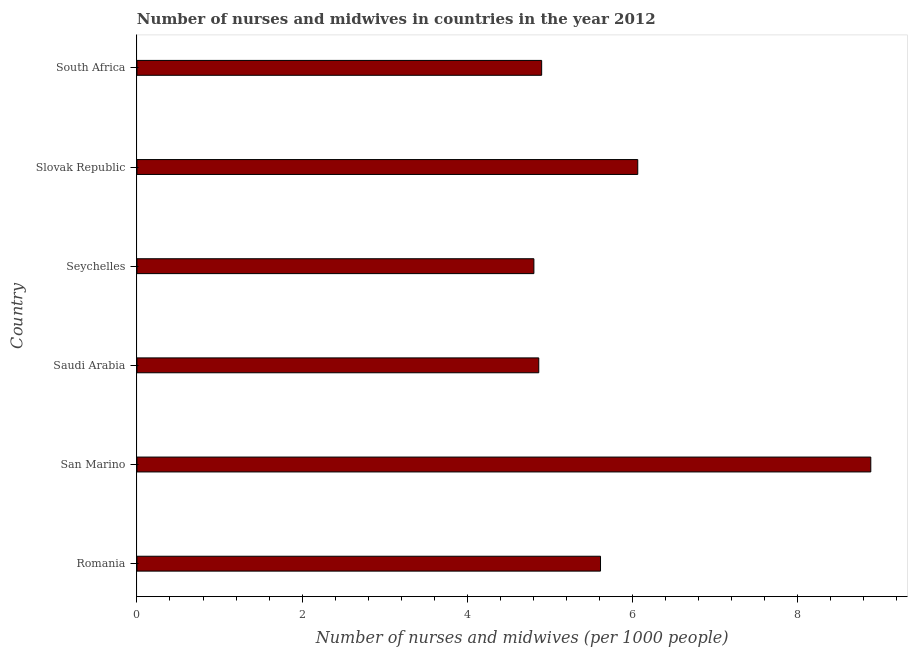Does the graph contain any zero values?
Provide a short and direct response. No. Does the graph contain grids?
Provide a succinct answer. No. What is the title of the graph?
Ensure brevity in your answer.  Number of nurses and midwives in countries in the year 2012. What is the label or title of the X-axis?
Your answer should be compact. Number of nurses and midwives (per 1000 people). What is the label or title of the Y-axis?
Make the answer very short. Country. What is the number of nurses and midwives in Romania?
Provide a short and direct response. 5.62. Across all countries, what is the maximum number of nurses and midwives?
Your answer should be very brief. 8.89. Across all countries, what is the minimum number of nurses and midwives?
Ensure brevity in your answer.  4.81. In which country was the number of nurses and midwives maximum?
Ensure brevity in your answer.  San Marino. In which country was the number of nurses and midwives minimum?
Offer a very short reply. Seychelles. What is the sum of the number of nurses and midwives?
Offer a very short reply. 35.15. What is the difference between the number of nurses and midwives in Romania and Seychelles?
Keep it short and to the point. 0.81. What is the average number of nurses and midwives per country?
Make the answer very short. 5.86. What is the median number of nurses and midwives?
Make the answer very short. 5.26. In how many countries, is the number of nurses and midwives greater than 7.2 ?
Offer a very short reply. 1. What is the ratio of the number of nurses and midwives in Romania to that in Slovak Republic?
Give a very brief answer. 0.93. Is the number of nurses and midwives in Romania less than that in Slovak Republic?
Your response must be concise. Yes. What is the difference between the highest and the second highest number of nurses and midwives?
Your answer should be very brief. 2.82. Is the sum of the number of nurses and midwives in Romania and San Marino greater than the maximum number of nurses and midwives across all countries?
Provide a succinct answer. Yes. What is the difference between the highest and the lowest number of nurses and midwives?
Provide a succinct answer. 4.08. How many bars are there?
Make the answer very short. 6. Are all the bars in the graph horizontal?
Your response must be concise. Yes. How many countries are there in the graph?
Offer a very short reply. 6. What is the difference between two consecutive major ticks on the X-axis?
Offer a very short reply. 2. What is the Number of nurses and midwives (per 1000 people) of Romania?
Your response must be concise. 5.62. What is the Number of nurses and midwives (per 1000 people) in San Marino?
Ensure brevity in your answer.  8.89. What is the Number of nurses and midwives (per 1000 people) in Saudi Arabia?
Provide a short and direct response. 4.87. What is the Number of nurses and midwives (per 1000 people) of Seychelles?
Ensure brevity in your answer.  4.81. What is the Number of nurses and midwives (per 1000 people) in Slovak Republic?
Your answer should be compact. 6.07. What is the Number of nurses and midwives (per 1000 people) in South Africa?
Provide a short and direct response. 4.9. What is the difference between the Number of nurses and midwives (per 1000 people) in Romania and San Marino?
Offer a terse response. -3.27. What is the difference between the Number of nurses and midwives (per 1000 people) in Romania and Saudi Arabia?
Give a very brief answer. 0.75. What is the difference between the Number of nurses and midwives (per 1000 people) in Romania and Seychelles?
Give a very brief answer. 0.81. What is the difference between the Number of nurses and midwives (per 1000 people) in Romania and Slovak Republic?
Provide a short and direct response. -0.45. What is the difference between the Number of nurses and midwives (per 1000 people) in Romania and South Africa?
Ensure brevity in your answer.  0.71. What is the difference between the Number of nurses and midwives (per 1000 people) in San Marino and Saudi Arabia?
Your answer should be compact. 4.02. What is the difference between the Number of nurses and midwives (per 1000 people) in San Marino and Seychelles?
Your answer should be very brief. 4.08. What is the difference between the Number of nurses and midwives (per 1000 people) in San Marino and Slovak Republic?
Give a very brief answer. 2.82. What is the difference between the Number of nurses and midwives (per 1000 people) in San Marino and South Africa?
Offer a terse response. 3.99. What is the difference between the Number of nurses and midwives (per 1000 people) in Saudi Arabia and Seychelles?
Offer a terse response. 0.06. What is the difference between the Number of nurses and midwives (per 1000 people) in Saudi Arabia and Slovak Republic?
Offer a terse response. -1.2. What is the difference between the Number of nurses and midwives (per 1000 people) in Saudi Arabia and South Africa?
Offer a very short reply. -0.04. What is the difference between the Number of nurses and midwives (per 1000 people) in Seychelles and Slovak Republic?
Make the answer very short. -1.26. What is the difference between the Number of nurses and midwives (per 1000 people) in Seychelles and South Africa?
Provide a short and direct response. -0.09. What is the difference between the Number of nurses and midwives (per 1000 people) in Slovak Republic and South Africa?
Your answer should be compact. 1.16. What is the ratio of the Number of nurses and midwives (per 1000 people) in Romania to that in San Marino?
Give a very brief answer. 0.63. What is the ratio of the Number of nurses and midwives (per 1000 people) in Romania to that in Saudi Arabia?
Provide a succinct answer. 1.15. What is the ratio of the Number of nurses and midwives (per 1000 people) in Romania to that in Seychelles?
Ensure brevity in your answer.  1.17. What is the ratio of the Number of nurses and midwives (per 1000 people) in Romania to that in Slovak Republic?
Offer a terse response. 0.93. What is the ratio of the Number of nurses and midwives (per 1000 people) in Romania to that in South Africa?
Your answer should be very brief. 1.15. What is the ratio of the Number of nurses and midwives (per 1000 people) in San Marino to that in Saudi Arabia?
Keep it short and to the point. 1.83. What is the ratio of the Number of nurses and midwives (per 1000 people) in San Marino to that in Seychelles?
Keep it short and to the point. 1.85. What is the ratio of the Number of nurses and midwives (per 1000 people) in San Marino to that in Slovak Republic?
Keep it short and to the point. 1.47. What is the ratio of the Number of nurses and midwives (per 1000 people) in San Marino to that in South Africa?
Your answer should be very brief. 1.81. What is the ratio of the Number of nurses and midwives (per 1000 people) in Saudi Arabia to that in Seychelles?
Give a very brief answer. 1.01. What is the ratio of the Number of nurses and midwives (per 1000 people) in Saudi Arabia to that in Slovak Republic?
Make the answer very short. 0.8. What is the ratio of the Number of nurses and midwives (per 1000 people) in Seychelles to that in Slovak Republic?
Give a very brief answer. 0.79. What is the ratio of the Number of nurses and midwives (per 1000 people) in Slovak Republic to that in South Africa?
Make the answer very short. 1.24. 